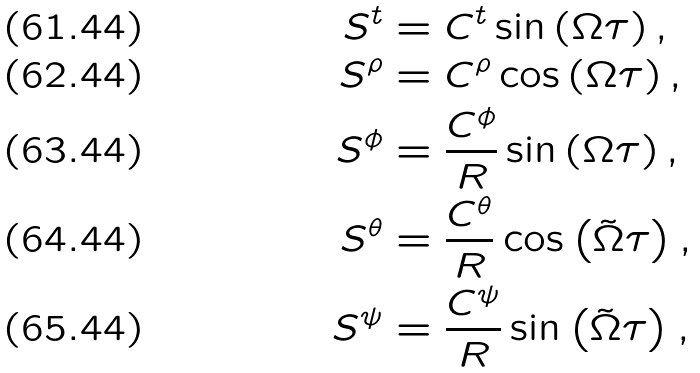<formula> <loc_0><loc_0><loc_500><loc_500>S ^ { t } & = C ^ { t } \sin \left ( \Omega \tau \right ) , \\ S ^ { \rho } & = C ^ { \rho } \cos \left ( \Omega \tau \right ) , \\ S ^ { \phi } & = \frac { C ^ { \phi } } { R } \sin \left ( \Omega \tau \right ) , \\ S ^ { \theta } & = \frac { C ^ { \theta } } { R } \cos \left ( \tilde { \Omega } \tau \right ) , \\ S ^ { \psi } & = \frac { C ^ { \psi } } { R } \sin \left ( \tilde { \Omega } \tau \right ) ,</formula> 